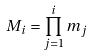<formula> <loc_0><loc_0><loc_500><loc_500>M _ { i } = \prod _ { j = 1 } ^ { i } m _ { j }</formula> 